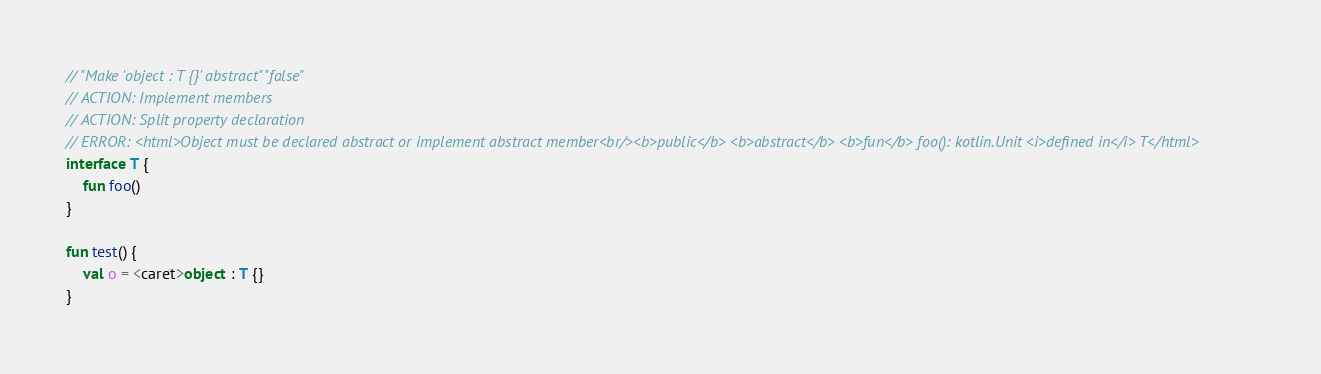<code> <loc_0><loc_0><loc_500><loc_500><_Kotlin_>// "Make 'object : T {}' abstract" "false"
// ACTION: Implement members
// ACTION: Split property declaration
// ERROR: <html>Object must be declared abstract or implement abstract member<br/><b>public</b> <b>abstract</b> <b>fun</b> foo(): kotlin.Unit <i>defined in</i> T</html>
interface T {
    fun foo()
}

fun test() {
    val o = <caret>object : T {}
}</code> 